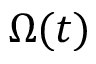<formula> <loc_0><loc_0><loc_500><loc_500>\Omega ( t )</formula> 